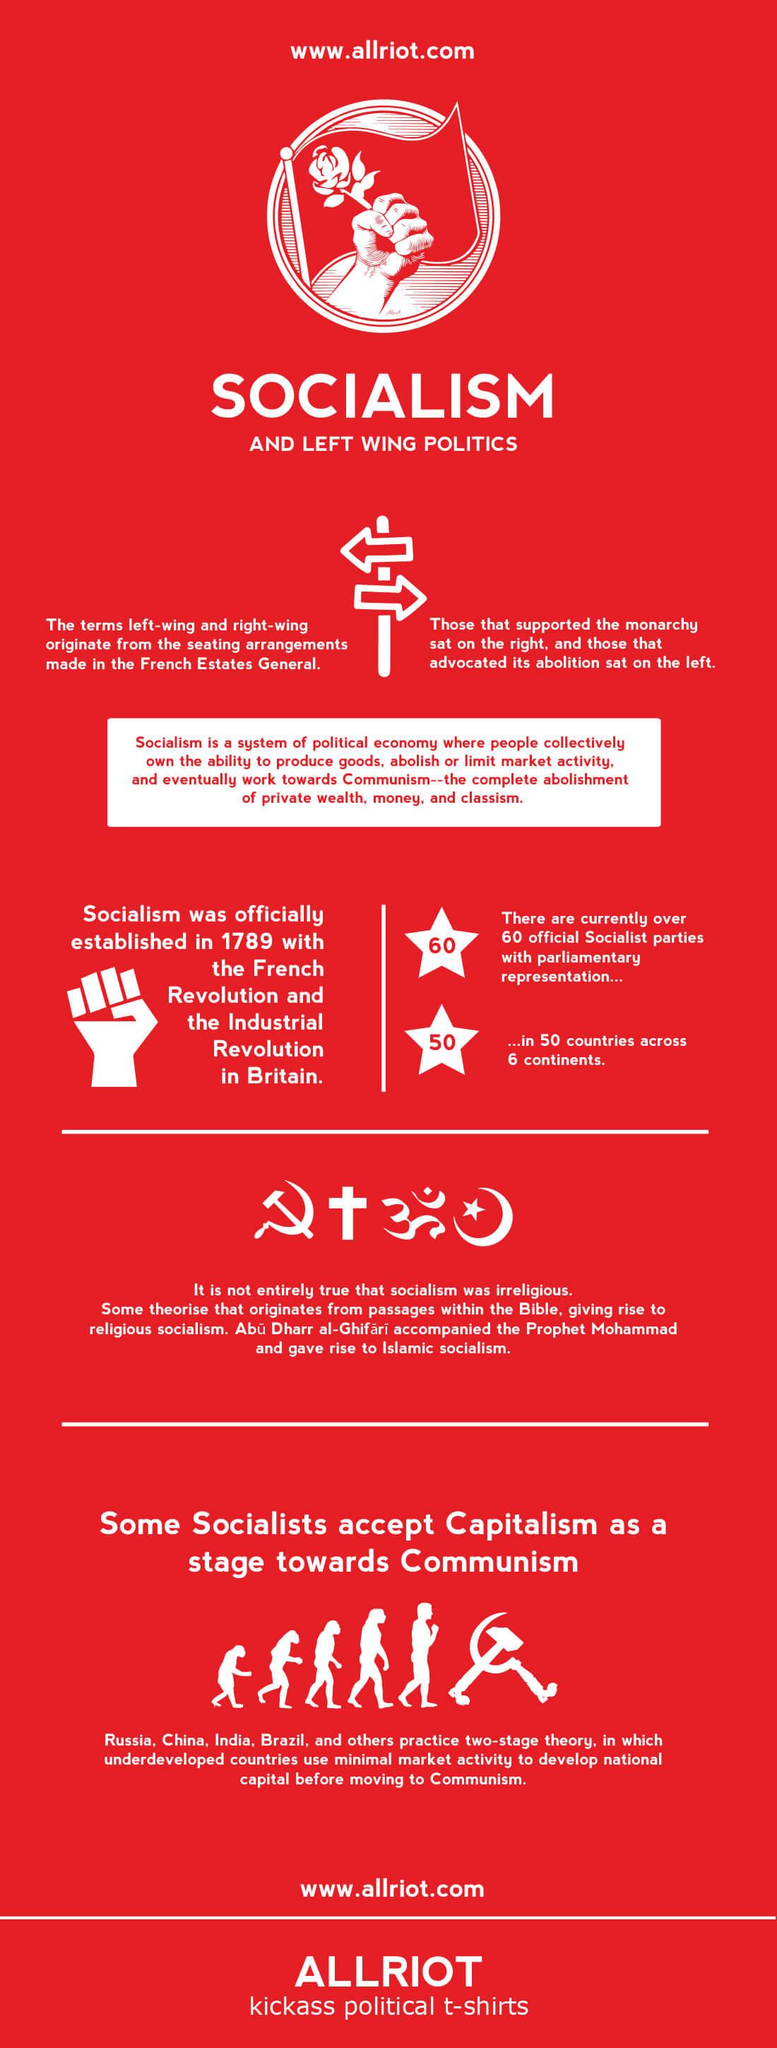Highlight a few significant elements in this photo. Those who favored monarchy were seated on the right side. 